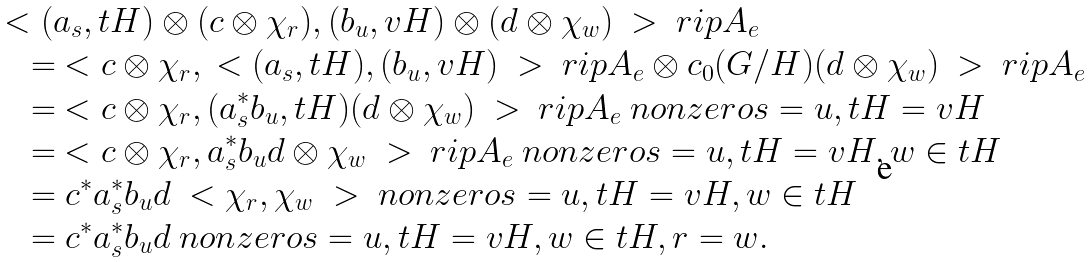<formula> <loc_0><loc_0><loc_500><loc_500>& \ < ( a _ { s } , t H ) \otimes ( c \otimes \chi _ { r } ) , ( b _ { u } , v H ) \otimes ( d \otimes \chi _ { w } ) \ > \ r i p { A _ { e } } \\ & \quad = \ < c \otimes \chi _ { r } , \ < ( a _ { s } , t H ) , ( b _ { u } , v H ) \ > \ r i p { A _ { e } \otimes c _ { 0 } ( G / H ) } ( d \otimes \chi _ { w } ) \ > \ r i p { A _ { e } } \\ & \quad = \ < c \otimes \chi _ { r } , ( a ^ { * } _ { s } b _ { u } , t H ) ( d \otimes \chi _ { w } ) \ > \ r i p { A _ { e } } \ n o n z e r o { s = u , t H = v H } \\ & \quad = \ < c \otimes \chi _ { r } , a ^ { * } _ { s } b _ { u } d \otimes \chi _ { w } \ > \ r i p { A _ { e } } \ n o n z e r o { s = u , t H = v H , w \in t H } \\ & \quad = c ^ { * } a ^ { * } _ { s } b _ { u } d \ < \chi _ { r } , \chi _ { w } \ > \ n o n z e r o { s = u , t H = v H , w \in t H } \\ & \quad = c ^ { * } a ^ { * } _ { s } b _ { u } d \ n o n z e r o { s = u , t H = v H , w \in t H , r = w } .</formula> 